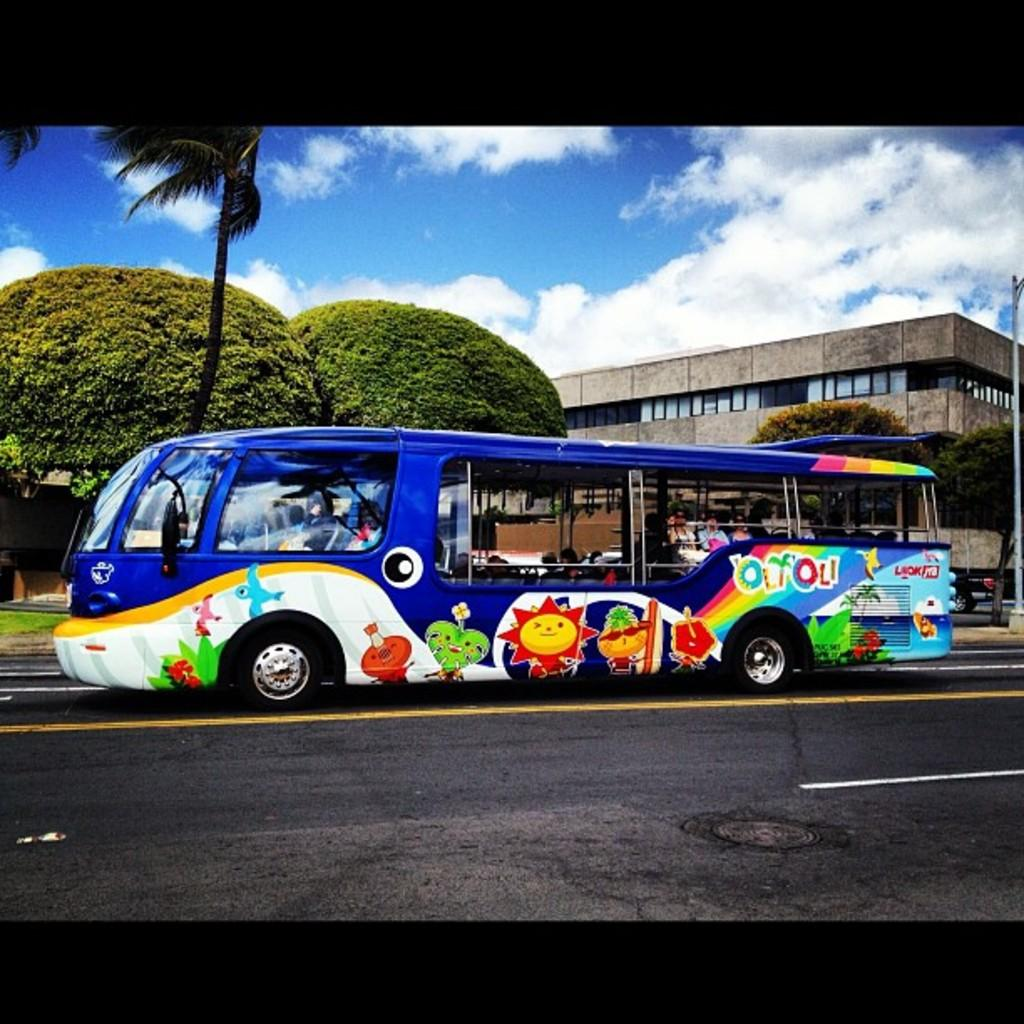<image>
Summarize the visual content of the image. A bus that says Olioli drives down the street. 